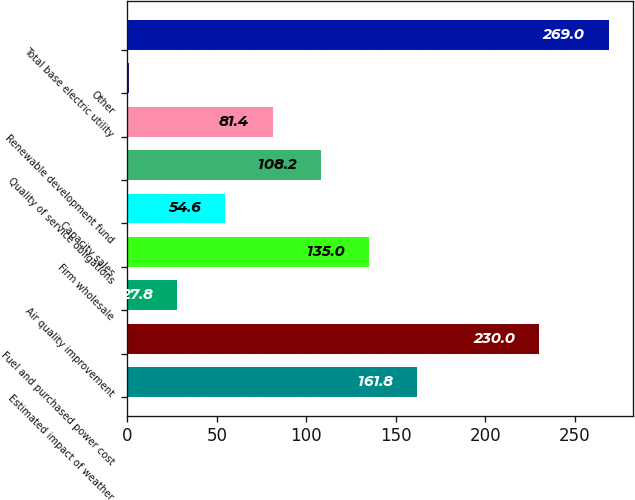<chart> <loc_0><loc_0><loc_500><loc_500><bar_chart><fcel>Estimated impact of weather<fcel>Fuel and purchased power cost<fcel>Air quality improvement<fcel>Firm wholesale<fcel>Capacity sales<fcel>Quality of service obligations<fcel>Renewable development fund<fcel>Other<fcel>Total base electric utility<nl><fcel>161.8<fcel>230<fcel>27.8<fcel>135<fcel>54.6<fcel>108.2<fcel>81.4<fcel>1<fcel>269<nl></chart> 